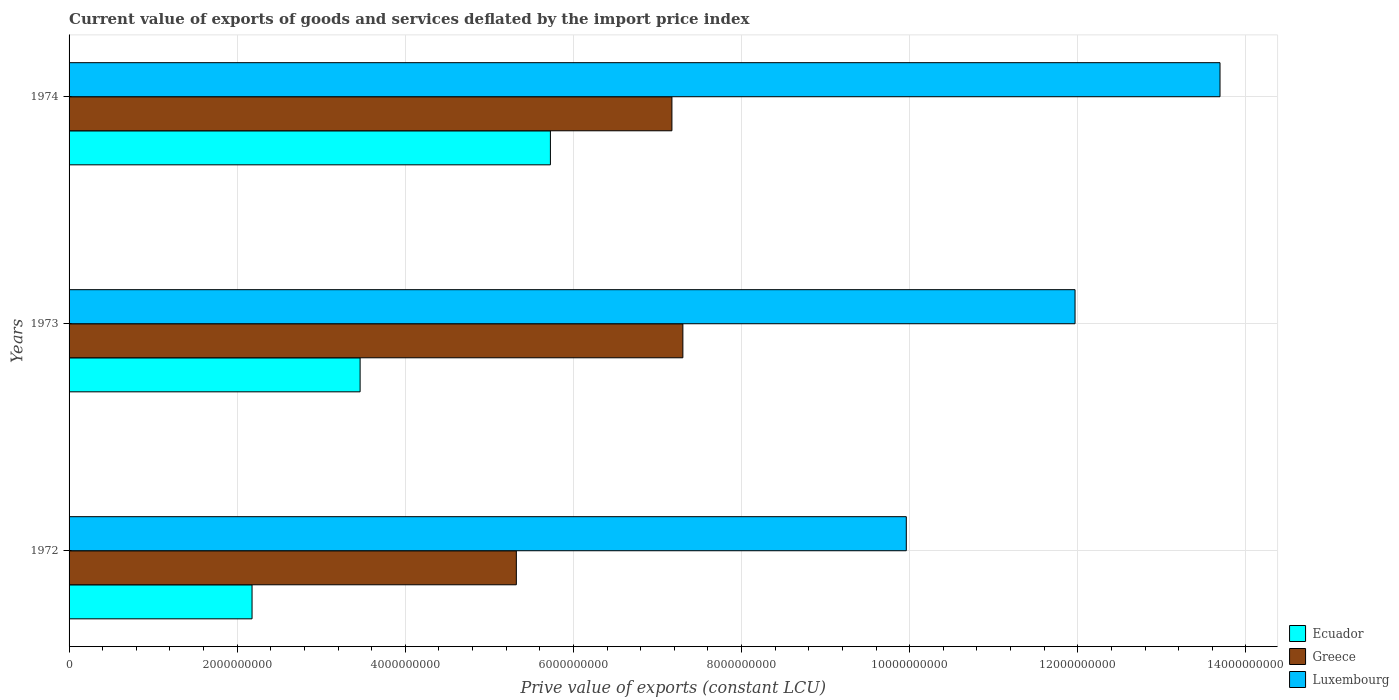Are the number of bars per tick equal to the number of legend labels?
Your answer should be very brief. Yes. Are the number of bars on each tick of the Y-axis equal?
Ensure brevity in your answer.  Yes. How many bars are there on the 3rd tick from the top?
Your answer should be very brief. 3. How many bars are there on the 1st tick from the bottom?
Offer a very short reply. 3. What is the label of the 1st group of bars from the top?
Ensure brevity in your answer.  1974. What is the prive value of exports in Ecuador in 1972?
Provide a short and direct response. 2.18e+09. Across all years, what is the maximum prive value of exports in Luxembourg?
Offer a terse response. 1.37e+1. Across all years, what is the minimum prive value of exports in Luxembourg?
Provide a succinct answer. 9.96e+09. What is the total prive value of exports in Luxembourg in the graph?
Your response must be concise. 3.56e+1. What is the difference between the prive value of exports in Luxembourg in 1972 and that in 1974?
Give a very brief answer. -3.73e+09. What is the difference between the prive value of exports in Ecuador in 1973 and the prive value of exports in Greece in 1974?
Your answer should be compact. -3.71e+09. What is the average prive value of exports in Ecuador per year?
Offer a terse response. 3.79e+09. In the year 1972, what is the difference between the prive value of exports in Greece and prive value of exports in Ecuador?
Give a very brief answer. 3.14e+09. In how many years, is the prive value of exports in Luxembourg greater than 4800000000 LCU?
Make the answer very short. 3. What is the ratio of the prive value of exports in Greece in 1972 to that in 1973?
Keep it short and to the point. 0.73. Is the difference between the prive value of exports in Greece in 1973 and 1974 greater than the difference between the prive value of exports in Ecuador in 1973 and 1974?
Make the answer very short. Yes. What is the difference between the highest and the second highest prive value of exports in Luxembourg?
Offer a terse response. 1.72e+09. What is the difference between the highest and the lowest prive value of exports in Luxembourg?
Provide a short and direct response. 3.73e+09. What does the 1st bar from the top in 1972 represents?
Ensure brevity in your answer.  Luxembourg. What does the 2nd bar from the bottom in 1974 represents?
Your answer should be very brief. Greece. Is it the case that in every year, the sum of the prive value of exports in Greece and prive value of exports in Luxembourg is greater than the prive value of exports in Ecuador?
Your answer should be compact. Yes. How many years are there in the graph?
Your response must be concise. 3. Does the graph contain grids?
Keep it short and to the point. Yes. Where does the legend appear in the graph?
Offer a very short reply. Bottom right. What is the title of the graph?
Ensure brevity in your answer.  Current value of exports of goods and services deflated by the import price index. What is the label or title of the X-axis?
Keep it short and to the point. Prive value of exports (constant LCU). What is the Prive value of exports (constant LCU) of Ecuador in 1972?
Your answer should be compact. 2.18e+09. What is the Prive value of exports (constant LCU) in Greece in 1972?
Make the answer very short. 5.32e+09. What is the Prive value of exports (constant LCU) in Luxembourg in 1972?
Your response must be concise. 9.96e+09. What is the Prive value of exports (constant LCU) in Ecuador in 1973?
Offer a very short reply. 3.46e+09. What is the Prive value of exports (constant LCU) in Greece in 1973?
Your answer should be very brief. 7.30e+09. What is the Prive value of exports (constant LCU) of Luxembourg in 1973?
Provide a succinct answer. 1.20e+1. What is the Prive value of exports (constant LCU) of Ecuador in 1974?
Ensure brevity in your answer.  5.73e+09. What is the Prive value of exports (constant LCU) in Greece in 1974?
Your response must be concise. 7.17e+09. What is the Prive value of exports (constant LCU) in Luxembourg in 1974?
Ensure brevity in your answer.  1.37e+1. Across all years, what is the maximum Prive value of exports (constant LCU) in Ecuador?
Ensure brevity in your answer.  5.73e+09. Across all years, what is the maximum Prive value of exports (constant LCU) of Greece?
Your response must be concise. 7.30e+09. Across all years, what is the maximum Prive value of exports (constant LCU) in Luxembourg?
Make the answer very short. 1.37e+1. Across all years, what is the minimum Prive value of exports (constant LCU) of Ecuador?
Provide a succinct answer. 2.18e+09. Across all years, what is the minimum Prive value of exports (constant LCU) in Greece?
Ensure brevity in your answer.  5.32e+09. Across all years, what is the minimum Prive value of exports (constant LCU) in Luxembourg?
Provide a short and direct response. 9.96e+09. What is the total Prive value of exports (constant LCU) in Ecuador in the graph?
Offer a very short reply. 1.14e+1. What is the total Prive value of exports (constant LCU) in Greece in the graph?
Provide a short and direct response. 1.98e+1. What is the total Prive value of exports (constant LCU) of Luxembourg in the graph?
Provide a short and direct response. 3.56e+1. What is the difference between the Prive value of exports (constant LCU) in Ecuador in 1972 and that in 1973?
Provide a succinct answer. -1.29e+09. What is the difference between the Prive value of exports (constant LCU) in Greece in 1972 and that in 1973?
Keep it short and to the point. -1.98e+09. What is the difference between the Prive value of exports (constant LCU) in Luxembourg in 1972 and that in 1973?
Ensure brevity in your answer.  -2.01e+09. What is the difference between the Prive value of exports (constant LCU) of Ecuador in 1972 and that in 1974?
Make the answer very short. -3.55e+09. What is the difference between the Prive value of exports (constant LCU) of Greece in 1972 and that in 1974?
Provide a succinct answer. -1.85e+09. What is the difference between the Prive value of exports (constant LCU) in Luxembourg in 1972 and that in 1974?
Your answer should be compact. -3.73e+09. What is the difference between the Prive value of exports (constant LCU) of Ecuador in 1973 and that in 1974?
Your answer should be very brief. -2.26e+09. What is the difference between the Prive value of exports (constant LCU) in Greece in 1973 and that in 1974?
Your answer should be compact. 1.30e+08. What is the difference between the Prive value of exports (constant LCU) in Luxembourg in 1973 and that in 1974?
Provide a succinct answer. -1.72e+09. What is the difference between the Prive value of exports (constant LCU) of Ecuador in 1972 and the Prive value of exports (constant LCU) of Greece in 1973?
Your answer should be very brief. -5.13e+09. What is the difference between the Prive value of exports (constant LCU) of Ecuador in 1972 and the Prive value of exports (constant LCU) of Luxembourg in 1973?
Your response must be concise. -9.79e+09. What is the difference between the Prive value of exports (constant LCU) in Greece in 1972 and the Prive value of exports (constant LCU) in Luxembourg in 1973?
Offer a terse response. -6.65e+09. What is the difference between the Prive value of exports (constant LCU) in Ecuador in 1972 and the Prive value of exports (constant LCU) in Greece in 1974?
Provide a succinct answer. -4.99e+09. What is the difference between the Prive value of exports (constant LCU) in Ecuador in 1972 and the Prive value of exports (constant LCU) in Luxembourg in 1974?
Provide a succinct answer. -1.15e+1. What is the difference between the Prive value of exports (constant LCU) of Greece in 1972 and the Prive value of exports (constant LCU) of Luxembourg in 1974?
Your answer should be compact. -8.37e+09. What is the difference between the Prive value of exports (constant LCU) in Ecuador in 1973 and the Prive value of exports (constant LCU) in Greece in 1974?
Keep it short and to the point. -3.71e+09. What is the difference between the Prive value of exports (constant LCU) in Ecuador in 1973 and the Prive value of exports (constant LCU) in Luxembourg in 1974?
Provide a succinct answer. -1.02e+1. What is the difference between the Prive value of exports (constant LCU) in Greece in 1973 and the Prive value of exports (constant LCU) in Luxembourg in 1974?
Make the answer very short. -6.39e+09. What is the average Prive value of exports (constant LCU) of Ecuador per year?
Give a very brief answer. 3.79e+09. What is the average Prive value of exports (constant LCU) of Greece per year?
Offer a terse response. 6.60e+09. What is the average Prive value of exports (constant LCU) in Luxembourg per year?
Give a very brief answer. 1.19e+1. In the year 1972, what is the difference between the Prive value of exports (constant LCU) of Ecuador and Prive value of exports (constant LCU) of Greece?
Provide a short and direct response. -3.14e+09. In the year 1972, what is the difference between the Prive value of exports (constant LCU) of Ecuador and Prive value of exports (constant LCU) of Luxembourg?
Keep it short and to the point. -7.78e+09. In the year 1972, what is the difference between the Prive value of exports (constant LCU) in Greece and Prive value of exports (constant LCU) in Luxembourg?
Your answer should be compact. -4.64e+09. In the year 1973, what is the difference between the Prive value of exports (constant LCU) of Ecuador and Prive value of exports (constant LCU) of Greece?
Offer a very short reply. -3.84e+09. In the year 1973, what is the difference between the Prive value of exports (constant LCU) of Ecuador and Prive value of exports (constant LCU) of Luxembourg?
Your answer should be compact. -8.50e+09. In the year 1973, what is the difference between the Prive value of exports (constant LCU) of Greece and Prive value of exports (constant LCU) of Luxembourg?
Your answer should be compact. -4.67e+09. In the year 1974, what is the difference between the Prive value of exports (constant LCU) in Ecuador and Prive value of exports (constant LCU) in Greece?
Ensure brevity in your answer.  -1.45e+09. In the year 1974, what is the difference between the Prive value of exports (constant LCU) in Ecuador and Prive value of exports (constant LCU) in Luxembourg?
Your response must be concise. -7.97e+09. In the year 1974, what is the difference between the Prive value of exports (constant LCU) in Greece and Prive value of exports (constant LCU) in Luxembourg?
Offer a terse response. -6.52e+09. What is the ratio of the Prive value of exports (constant LCU) of Ecuador in 1972 to that in 1973?
Offer a very short reply. 0.63. What is the ratio of the Prive value of exports (constant LCU) in Greece in 1972 to that in 1973?
Make the answer very short. 0.73. What is the ratio of the Prive value of exports (constant LCU) in Luxembourg in 1972 to that in 1973?
Make the answer very short. 0.83. What is the ratio of the Prive value of exports (constant LCU) in Ecuador in 1972 to that in 1974?
Your answer should be compact. 0.38. What is the ratio of the Prive value of exports (constant LCU) in Greece in 1972 to that in 1974?
Offer a very short reply. 0.74. What is the ratio of the Prive value of exports (constant LCU) in Luxembourg in 1972 to that in 1974?
Your response must be concise. 0.73. What is the ratio of the Prive value of exports (constant LCU) in Ecuador in 1973 to that in 1974?
Your response must be concise. 0.6. What is the ratio of the Prive value of exports (constant LCU) of Greece in 1973 to that in 1974?
Make the answer very short. 1.02. What is the ratio of the Prive value of exports (constant LCU) of Luxembourg in 1973 to that in 1974?
Your answer should be very brief. 0.87. What is the difference between the highest and the second highest Prive value of exports (constant LCU) in Ecuador?
Provide a succinct answer. 2.26e+09. What is the difference between the highest and the second highest Prive value of exports (constant LCU) of Greece?
Offer a very short reply. 1.30e+08. What is the difference between the highest and the second highest Prive value of exports (constant LCU) of Luxembourg?
Your answer should be compact. 1.72e+09. What is the difference between the highest and the lowest Prive value of exports (constant LCU) of Ecuador?
Your response must be concise. 3.55e+09. What is the difference between the highest and the lowest Prive value of exports (constant LCU) of Greece?
Provide a succinct answer. 1.98e+09. What is the difference between the highest and the lowest Prive value of exports (constant LCU) of Luxembourg?
Make the answer very short. 3.73e+09. 